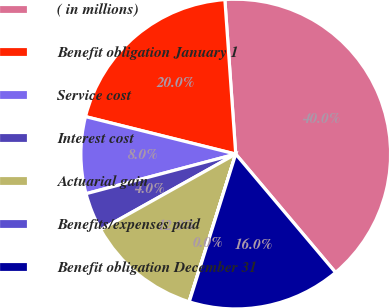Convert chart. <chart><loc_0><loc_0><loc_500><loc_500><pie_chart><fcel>( in millions)<fcel>Benefit obligation January 1<fcel>Service cost<fcel>Interest cost<fcel>Actuarial gain<fcel>Benefits/expenses paid<fcel>Benefit obligation December 31<nl><fcel>39.97%<fcel>19.99%<fcel>8.01%<fcel>4.01%<fcel>12.0%<fcel>0.02%<fcel>16.0%<nl></chart> 